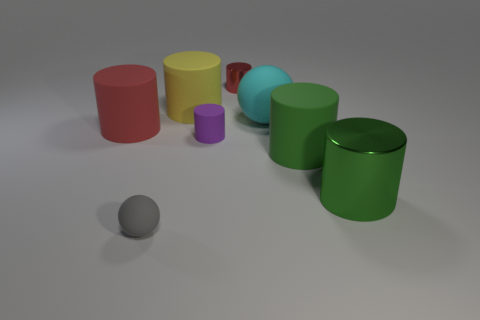The other shiny object that is the same shape as the tiny red object is what color?
Ensure brevity in your answer.  Green. There is a large yellow matte thing that is to the left of the tiny cylinder that is behind the object to the left of the small gray ball; what shape is it?
Provide a succinct answer. Cylinder. Does the big red rubber object have the same shape as the big yellow rubber thing?
Ensure brevity in your answer.  Yes. Is there a tiny red metallic object that has the same shape as the gray object?
Make the answer very short. No. There is a red matte thing that is the same size as the cyan object; what is its shape?
Your answer should be very brief. Cylinder. What material is the cylinder to the left of the yellow rubber object on the right side of the red thing to the left of the tiny gray object?
Your answer should be very brief. Rubber. Do the red matte cylinder and the green metallic cylinder have the same size?
Your answer should be very brief. Yes. What is the cyan sphere made of?
Provide a short and direct response. Rubber. There is a large cylinder that is the same color as the small metal cylinder; what is it made of?
Provide a succinct answer. Rubber. Does the green metallic object to the right of the big yellow matte cylinder have the same shape as the purple object?
Your answer should be very brief. Yes. 